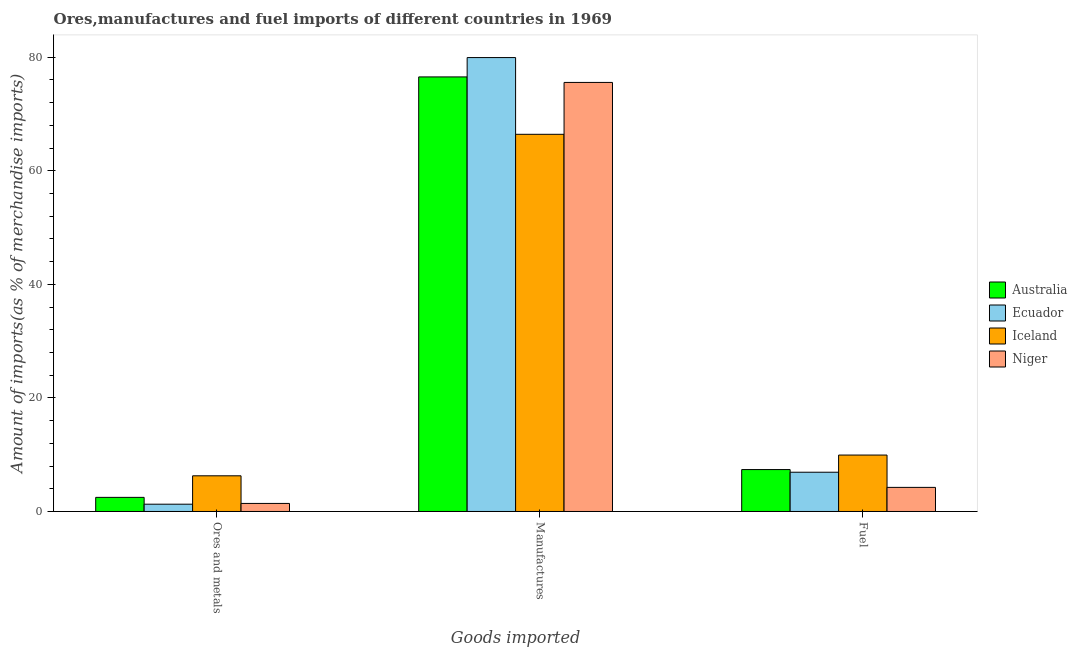How many different coloured bars are there?
Provide a short and direct response. 4. Are the number of bars on each tick of the X-axis equal?
Ensure brevity in your answer.  Yes. What is the label of the 3rd group of bars from the left?
Your response must be concise. Fuel. What is the percentage of manufactures imports in Australia?
Provide a succinct answer. 76.52. Across all countries, what is the maximum percentage of manufactures imports?
Offer a terse response. 79.92. Across all countries, what is the minimum percentage of fuel imports?
Your response must be concise. 4.24. In which country was the percentage of ores and metals imports maximum?
Your answer should be compact. Iceland. In which country was the percentage of fuel imports minimum?
Offer a terse response. Niger. What is the total percentage of fuel imports in the graph?
Offer a terse response. 28.47. What is the difference between the percentage of manufactures imports in Niger and that in Ecuador?
Your answer should be compact. -4.38. What is the difference between the percentage of fuel imports in Niger and the percentage of manufactures imports in Australia?
Your answer should be compact. -72.28. What is the average percentage of ores and metals imports per country?
Ensure brevity in your answer.  2.87. What is the difference between the percentage of fuel imports and percentage of ores and metals imports in Niger?
Make the answer very short. 2.82. In how many countries, is the percentage of manufactures imports greater than 48 %?
Your answer should be very brief. 4. What is the ratio of the percentage of ores and metals imports in Iceland to that in Ecuador?
Keep it short and to the point. 4.9. What is the difference between the highest and the second highest percentage of ores and metals imports?
Your answer should be very brief. 3.8. What is the difference between the highest and the lowest percentage of ores and metals imports?
Provide a short and direct response. 5. Is the sum of the percentage of ores and metals imports in Iceland and Niger greater than the maximum percentage of manufactures imports across all countries?
Your response must be concise. No. What does the 3rd bar from the right in Ores and metals represents?
Provide a short and direct response. Ecuador. Is it the case that in every country, the sum of the percentage of ores and metals imports and percentage of manufactures imports is greater than the percentage of fuel imports?
Provide a short and direct response. Yes. How many bars are there?
Offer a very short reply. 12. Are the values on the major ticks of Y-axis written in scientific E-notation?
Ensure brevity in your answer.  No. How are the legend labels stacked?
Give a very brief answer. Vertical. What is the title of the graph?
Offer a terse response. Ores,manufactures and fuel imports of different countries in 1969. What is the label or title of the X-axis?
Offer a very short reply. Goods imported. What is the label or title of the Y-axis?
Your answer should be very brief. Amount of imports(as % of merchandise imports). What is the Amount of imports(as % of merchandise imports) in Australia in Ores and metals?
Your response must be concise. 2.49. What is the Amount of imports(as % of merchandise imports) in Ecuador in Ores and metals?
Your answer should be very brief. 1.28. What is the Amount of imports(as % of merchandise imports) in Iceland in Ores and metals?
Ensure brevity in your answer.  6.28. What is the Amount of imports(as % of merchandise imports) of Niger in Ores and metals?
Your response must be concise. 1.42. What is the Amount of imports(as % of merchandise imports) of Australia in Manufactures?
Offer a very short reply. 76.52. What is the Amount of imports(as % of merchandise imports) of Ecuador in Manufactures?
Give a very brief answer. 79.92. What is the Amount of imports(as % of merchandise imports) in Iceland in Manufactures?
Provide a short and direct response. 66.41. What is the Amount of imports(as % of merchandise imports) in Niger in Manufactures?
Make the answer very short. 75.55. What is the Amount of imports(as % of merchandise imports) of Australia in Fuel?
Make the answer very short. 7.38. What is the Amount of imports(as % of merchandise imports) in Ecuador in Fuel?
Offer a very short reply. 6.91. What is the Amount of imports(as % of merchandise imports) in Iceland in Fuel?
Ensure brevity in your answer.  9.93. What is the Amount of imports(as % of merchandise imports) of Niger in Fuel?
Your answer should be very brief. 4.24. Across all Goods imported, what is the maximum Amount of imports(as % of merchandise imports) in Australia?
Provide a succinct answer. 76.52. Across all Goods imported, what is the maximum Amount of imports(as % of merchandise imports) in Ecuador?
Offer a terse response. 79.92. Across all Goods imported, what is the maximum Amount of imports(as % of merchandise imports) in Iceland?
Keep it short and to the point. 66.41. Across all Goods imported, what is the maximum Amount of imports(as % of merchandise imports) of Niger?
Offer a very short reply. 75.55. Across all Goods imported, what is the minimum Amount of imports(as % of merchandise imports) in Australia?
Your answer should be very brief. 2.49. Across all Goods imported, what is the minimum Amount of imports(as % of merchandise imports) of Ecuador?
Make the answer very short. 1.28. Across all Goods imported, what is the minimum Amount of imports(as % of merchandise imports) in Iceland?
Keep it short and to the point. 6.28. Across all Goods imported, what is the minimum Amount of imports(as % of merchandise imports) of Niger?
Your response must be concise. 1.42. What is the total Amount of imports(as % of merchandise imports) in Australia in the graph?
Provide a succinct answer. 86.38. What is the total Amount of imports(as % of merchandise imports) in Ecuador in the graph?
Your response must be concise. 88.12. What is the total Amount of imports(as % of merchandise imports) in Iceland in the graph?
Offer a very short reply. 82.63. What is the total Amount of imports(as % of merchandise imports) of Niger in the graph?
Your answer should be very brief. 81.21. What is the difference between the Amount of imports(as % of merchandise imports) of Australia in Ores and metals and that in Manufactures?
Provide a short and direct response. -74.03. What is the difference between the Amount of imports(as % of merchandise imports) in Ecuador in Ores and metals and that in Manufactures?
Provide a short and direct response. -78.64. What is the difference between the Amount of imports(as % of merchandise imports) in Iceland in Ores and metals and that in Manufactures?
Your answer should be very brief. -60.13. What is the difference between the Amount of imports(as % of merchandise imports) in Niger in Ores and metals and that in Manufactures?
Make the answer very short. -74.13. What is the difference between the Amount of imports(as % of merchandise imports) in Australia in Ores and metals and that in Fuel?
Your response must be concise. -4.89. What is the difference between the Amount of imports(as % of merchandise imports) of Ecuador in Ores and metals and that in Fuel?
Provide a succinct answer. -5.63. What is the difference between the Amount of imports(as % of merchandise imports) in Iceland in Ores and metals and that in Fuel?
Offer a very short reply. -3.65. What is the difference between the Amount of imports(as % of merchandise imports) in Niger in Ores and metals and that in Fuel?
Keep it short and to the point. -2.82. What is the difference between the Amount of imports(as % of merchandise imports) in Australia in Manufactures and that in Fuel?
Your response must be concise. 69.14. What is the difference between the Amount of imports(as % of merchandise imports) in Ecuador in Manufactures and that in Fuel?
Keep it short and to the point. 73.01. What is the difference between the Amount of imports(as % of merchandise imports) in Iceland in Manufactures and that in Fuel?
Make the answer very short. 56.48. What is the difference between the Amount of imports(as % of merchandise imports) of Niger in Manufactures and that in Fuel?
Offer a very short reply. 71.31. What is the difference between the Amount of imports(as % of merchandise imports) of Australia in Ores and metals and the Amount of imports(as % of merchandise imports) of Ecuador in Manufactures?
Your answer should be very brief. -77.44. What is the difference between the Amount of imports(as % of merchandise imports) of Australia in Ores and metals and the Amount of imports(as % of merchandise imports) of Iceland in Manufactures?
Your answer should be compact. -63.93. What is the difference between the Amount of imports(as % of merchandise imports) of Australia in Ores and metals and the Amount of imports(as % of merchandise imports) of Niger in Manufactures?
Make the answer very short. -73.06. What is the difference between the Amount of imports(as % of merchandise imports) of Ecuador in Ores and metals and the Amount of imports(as % of merchandise imports) of Iceland in Manufactures?
Make the answer very short. -65.13. What is the difference between the Amount of imports(as % of merchandise imports) in Ecuador in Ores and metals and the Amount of imports(as % of merchandise imports) in Niger in Manufactures?
Offer a very short reply. -74.27. What is the difference between the Amount of imports(as % of merchandise imports) of Iceland in Ores and metals and the Amount of imports(as % of merchandise imports) of Niger in Manufactures?
Give a very brief answer. -69.27. What is the difference between the Amount of imports(as % of merchandise imports) of Australia in Ores and metals and the Amount of imports(as % of merchandise imports) of Ecuador in Fuel?
Your answer should be compact. -4.43. What is the difference between the Amount of imports(as % of merchandise imports) in Australia in Ores and metals and the Amount of imports(as % of merchandise imports) in Iceland in Fuel?
Offer a very short reply. -7.45. What is the difference between the Amount of imports(as % of merchandise imports) of Australia in Ores and metals and the Amount of imports(as % of merchandise imports) of Niger in Fuel?
Keep it short and to the point. -1.76. What is the difference between the Amount of imports(as % of merchandise imports) of Ecuador in Ores and metals and the Amount of imports(as % of merchandise imports) of Iceland in Fuel?
Keep it short and to the point. -8.65. What is the difference between the Amount of imports(as % of merchandise imports) in Ecuador in Ores and metals and the Amount of imports(as % of merchandise imports) in Niger in Fuel?
Keep it short and to the point. -2.96. What is the difference between the Amount of imports(as % of merchandise imports) in Iceland in Ores and metals and the Amount of imports(as % of merchandise imports) in Niger in Fuel?
Give a very brief answer. 2.04. What is the difference between the Amount of imports(as % of merchandise imports) of Australia in Manufactures and the Amount of imports(as % of merchandise imports) of Ecuador in Fuel?
Offer a terse response. 69.61. What is the difference between the Amount of imports(as % of merchandise imports) in Australia in Manufactures and the Amount of imports(as % of merchandise imports) in Iceland in Fuel?
Provide a succinct answer. 66.58. What is the difference between the Amount of imports(as % of merchandise imports) in Australia in Manufactures and the Amount of imports(as % of merchandise imports) in Niger in Fuel?
Offer a very short reply. 72.28. What is the difference between the Amount of imports(as % of merchandise imports) in Ecuador in Manufactures and the Amount of imports(as % of merchandise imports) in Iceland in Fuel?
Your answer should be very brief. 69.99. What is the difference between the Amount of imports(as % of merchandise imports) of Ecuador in Manufactures and the Amount of imports(as % of merchandise imports) of Niger in Fuel?
Provide a short and direct response. 75.68. What is the difference between the Amount of imports(as % of merchandise imports) of Iceland in Manufactures and the Amount of imports(as % of merchandise imports) of Niger in Fuel?
Offer a very short reply. 62.17. What is the average Amount of imports(as % of merchandise imports) of Australia per Goods imported?
Your answer should be compact. 28.8. What is the average Amount of imports(as % of merchandise imports) in Ecuador per Goods imported?
Your answer should be very brief. 29.37. What is the average Amount of imports(as % of merchandise imports) of Iceland per Goods imported?
Make the answer very short. 27.54. What is the average Amount of imports(as % of merchandise imports) in Niger per Goods imported?
Your answer should be compact. 27.07. What is the difference between the Amount of imports(as % of merchandise imports) of Australia and Amount of imports(as % of merchandise imports) of Ecuador in Ores and metals?
Ensure brevity in your answer.  1.2. What is the difference between the Amount of imports(as % of merchandise imports) in Australia and Amount of imports(as % of merchandise imports) in Iceland in Ores and metals?
Offer a terse response. -3.8. What is the difference between the Amount of imports(as % of merchandise imports) of Australia and Amount of imports(as % of merchandise imports) of Niger in Ores and metals?
Keep it short and to the point. 1.07. What is the difference between the Amount of imports(as % of merchandise imports) of Ecuador and Amount of imports(as % of merchandise imports) of Iceland in Ores and metals?
Ensure brevity in your answer.  -5. What is the difference between the Amount of imports(as % of merchandise imports) in Ecuador and Amount of imports(as % of merchandise imports) in Niger in Ores and metals?
Offer a very short reply. -0.14. What is the difference between the Amount of imports(as % of merchandise imports) of Iceland and Amount of imports(as % of merchandise imports) of Niger in Ores and metals?
Offer a very short reply. 4.86. What is the difference between the Amount of imports(as % of merchandise imports) in Australia and Amount of imports(as % of merchandise imports) in Ecuador in Manufactures?
Provide a short and direct response. -3.41. What is the difference between the Amount of imports(as % of merchandise imports) in Australia and Amount of imports(as % of merchandise imports) in Iceland in Manufactures?
Your answer should be very brief. 10.11. What is the difference between the Amount of imports(as % of merchandise imports) in Australia and Amount of imports(as % of merchandise imports) in Niger in Manufactures?
Your response must be concise. 0.97. What is the difference between the Amount of imports(as % of merchandise imports) of Ecuador and Amount of imports(as % of merchandise imports) of Iceland in Manufactures?
Your answer should be very brief. 13.51. What is the difference between the Amount of imports(as % of merchandise imports) of Ecuador and Amount of imports(as % of merchandise imports) of Niger in Manufactures?
Your answer should be compact. 4.38. What is the difference between the Amount of imports(as % of merchandise imports) of Iceland and Amount of imports(as % of merchandise imports) of Niger in Manufactures?
Offer a terse response. -9.14. What is the difference between the Amount of imports(as % of merchandise imports) of Australia and Amount of imports(as % of merchandise imports) of Ecuador in Fuel?
Offer a very short reply. 0.47. What is the difference between the Amount of imports(as % of merchandise imports) of Australia and Amount of imports(as % of merchandise imports) of Iceland in Fuel?
Offer a terse response. -2.55. What is the difference between the Amount of imports(as % of merchandise imports) of Australia and Amount of imports(as % of merchandise imports) of Niger in Fuel?
Ensure brevity in your answer.  3.14. What is the difference between the Amount of imports(as % of merchandise imports) in Ecuador and Amount of imports(as % of merchandise imports) in Iceland in Fuel?
Your answer should be compact. -3.02. What is the difference between the Amount of imports(as % of merchandise imports) in Ecuador and Amount of imports(as % of merchandise imports) in Niger in Fuel?
Your answer should be compact. 2.67. What is the difference between the Amount of imports(as % of merchandise imports) of Iceland and Amount of imports(as % of merchandise imports) of Niger in Fuel?
Give a very brief answer. 5.69. What is the ratio of the Amount of imports(as % of merchandise imports) in Australia in Ores and metals to that in Manufactures?
Provide a short and direct response. 0.03. What is the ratio of the Amount of imports(as % of merchandise imports) of Ecuador in Ores and metals to that in Manufactures?
Offer a very short reply. 0.02. What is the ratio of the Amount of imports(as % of merchandise imports) of Iceland in Ores and metals to that in Manufactures?
Provide a short and direct response. 0.09. What is the ratio of the Amount of imports(as % of merchandise imports) of Niger in Ores and metals to that in Manufactures?
Your answer should be compact. 0.02. What is the ratio of the Amount of imports(as % of merchandise imports) in Australia in Ores and metals to that in Fuel?
Give a very brief answer. 0.34. What is the ratio of the Amount of imports(as % of merchandise imports) of Ecuador in Ores and metals to that in Fuel?
Offer a terse response. 0.19. What is the ratio of the Amount of imports(as % of merchandise imports) in Iceland in Ores and metals to that in Fuel?
Make the answer very short. 0.63. What is the ratio of the Amount of imports(as % of merchandise imports) of Niger in Ores and metals to that in Fuel?
Offer a terse response. 0.33. What is the ratio of the Amount of imports(as % of merchandise imports) in Australia in Manufactures to that in Fuel?
Your response must be concise. 10.37. What is the ratio of the Amount of imports(as % of merchandise imports) in Ecuador in Manufactures to that in Fuel?
Give a very brief answer. 11.56. What is the ratio of the Amount of imports(as % of merchandise imports) of Iceland in Manufactures to that in Fuel?
Offer a very short reply. 6.68. What is the ratio of the Amount of imports(as % of merchandise imports) in Niger in Manufactures to that in Fuel?
Your response must be concise. 17.8. What is the difference between the highest and the second highest Amount of imports(as % of merchandise imports) of Australia?
Give a very brief answer. 69.14. What is the difference between the highest and the second highest Amount of imports(as % of merchandise imports) in Ecuador?
Offer a very short reply. 73.01. What is the difference between the highest and the second highest Amount of imports(as % of merchandise imports) in Iceland?
Your answer should be compact. 56.48. What is the difference between the highest and the second highest Amount of imports(as % of merchandise imports) of Niger?
Offer a very short reply. 71.31. What is the difference between the highest and the lowest Amount of imports(as % of merchandise imports) in Australia?
Provide a short and direct response. 74.03. What is the difference between the highest and the lowest Amount of imports(as % of merchandise imports) in Ecuador?
Your answer should be very brief. 78.64. What is the difference between the highest and the lowest Amount of imports(as % of merchandise imports) in Iceland?
Make the answer very short. 60.13. What is the difference between the highest and the lowest Amount of imports(as % of merchandise imports) of Niger?
Your answer should be compact. 74.13. 